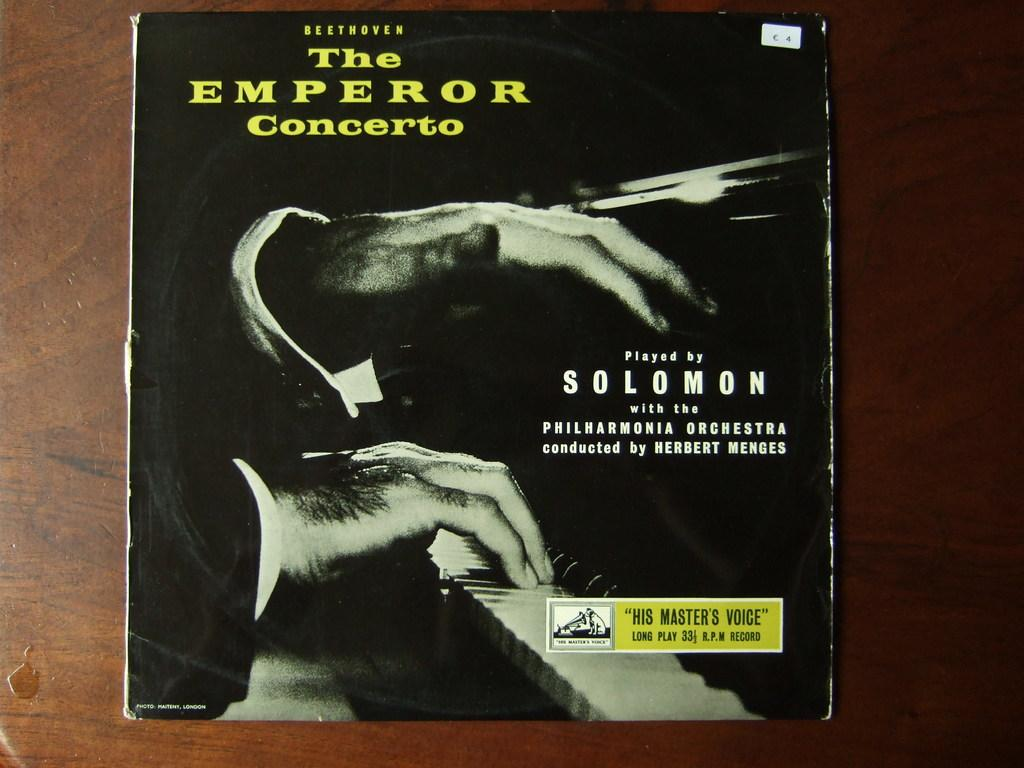<image>
Describe the image concisely. A record cover of The Emperor Concerto has an image of a piano on it. 